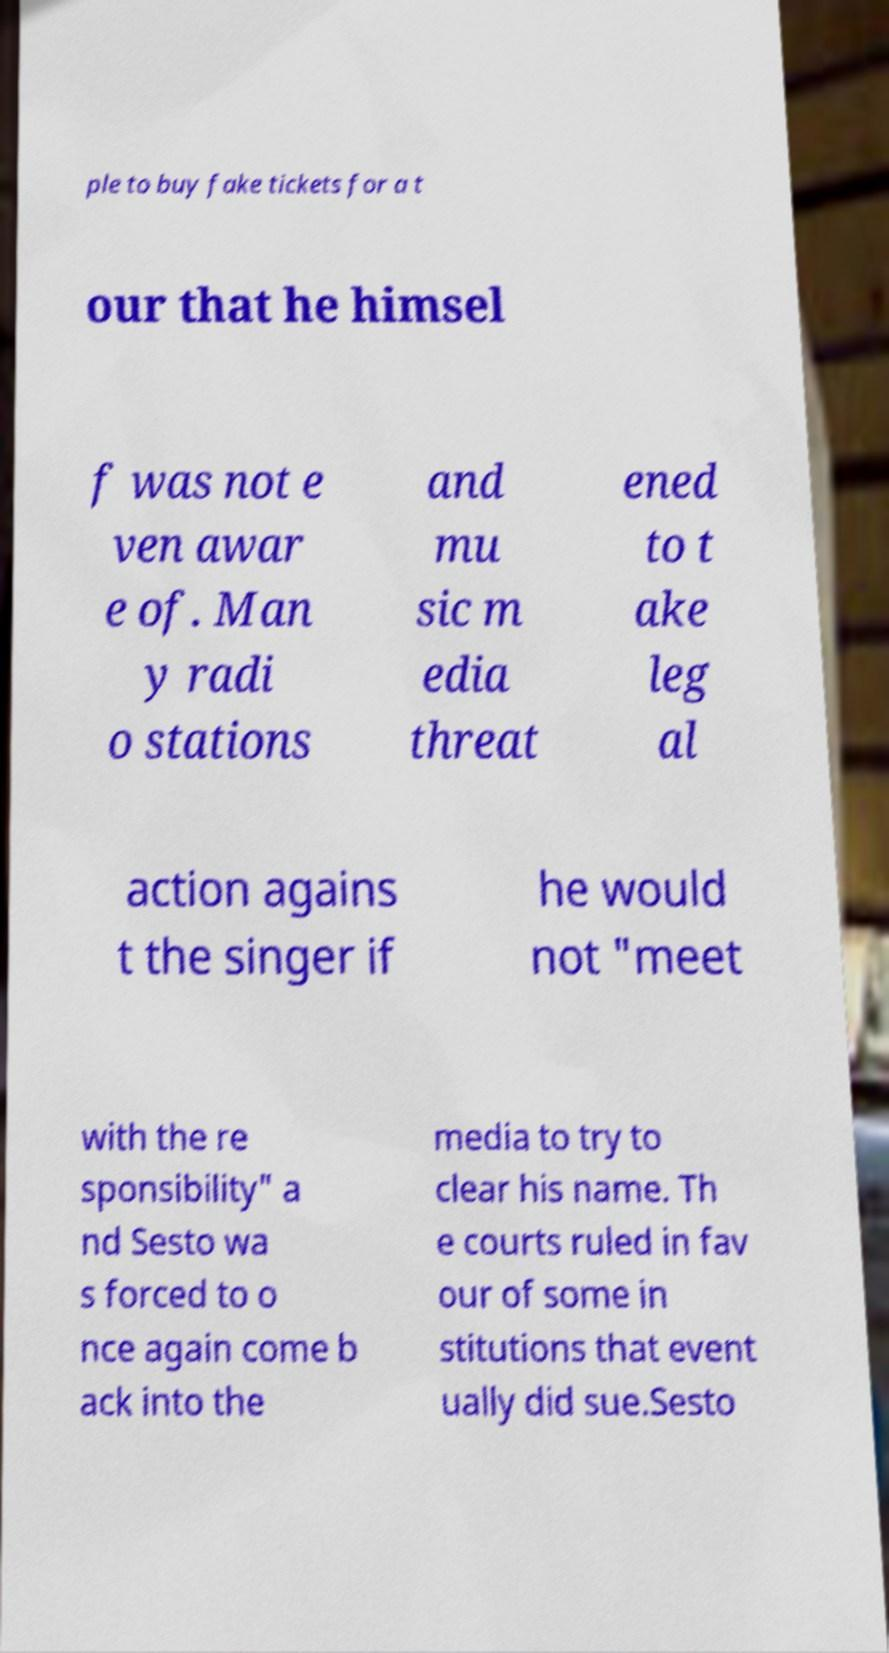There's text embedded in this image that I need extracted. Can you transcribe it verbatim? ple to buy fake tickets for a t our that he himsel f was not e ven awar e of. Man y radi o stations and mu sic m edia threat ened to t ake leg al action agains t the singer if he would not "meet with the re sponsibility" a nd Sesto wa s forced to o nce again come b ack into the media to try to clear his name. Th e courts ruled in fav our of some in stitutions that event ually did sue.Sesto 